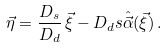Convert formula to latex. <formula><loc_0><loc_0><loc_500><loc_500>\vec { \eta } = \frac { D _ { s } } { D _ { d } } \, \vec { \xi } - D _ { d } s \hat { \vec { \alpha } } ( \vec { \xi } ) \, .</formula> 